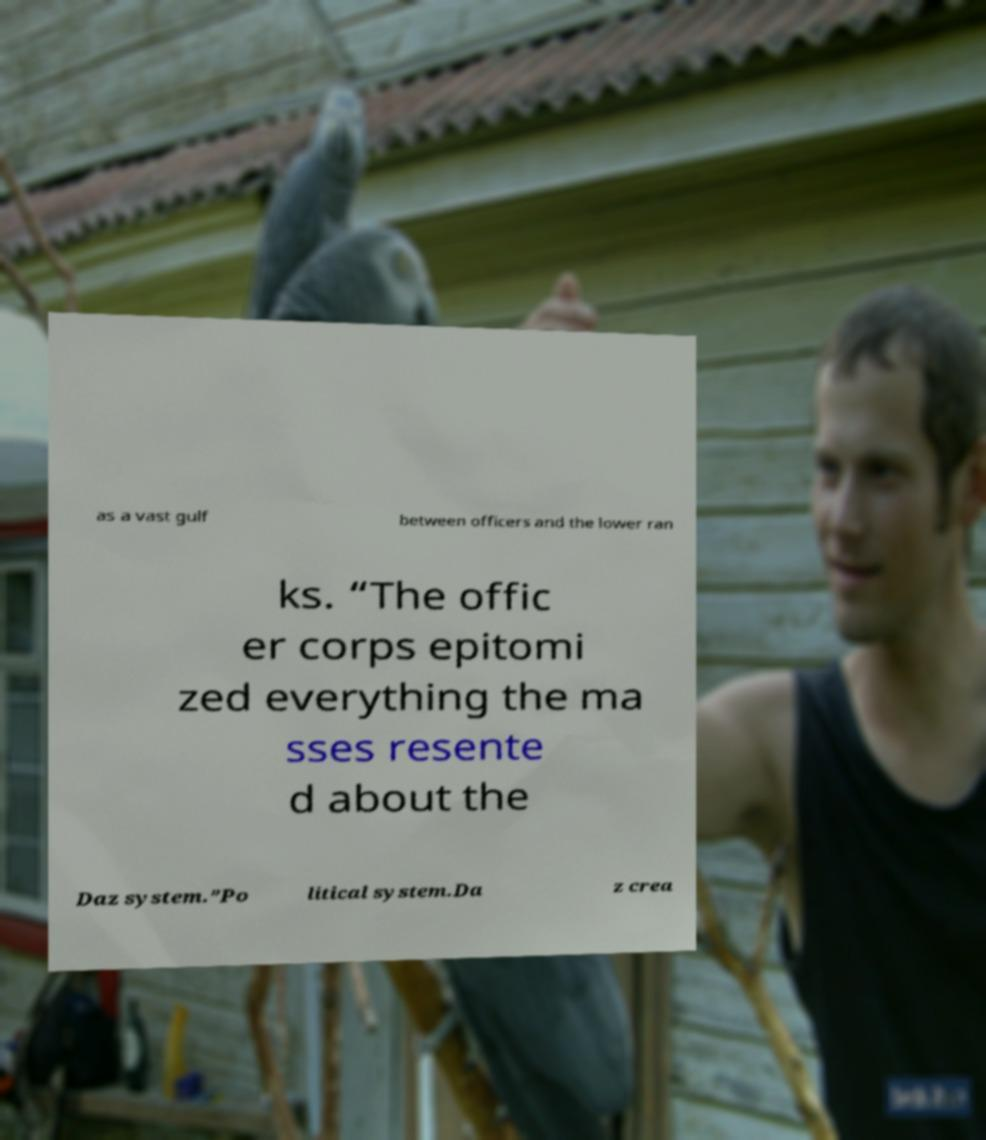Could you extract and type out the text from this image? as a vast gulf between officers and the lower ran ks. “The offic er corps epitomi zed everything the ma sses resente d about the Daz system.”Po litical system.Da z crea 